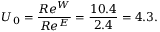Convert formula to latex. <formula><loc_0><loc_0><loc_500><loc_500>U _ { 0 } = \frac { R e ^ { W } } { R e ^ { E } } = \frac { 1 0 . 4 } { 2 . 4 } = 4 . 3 .</formula> 